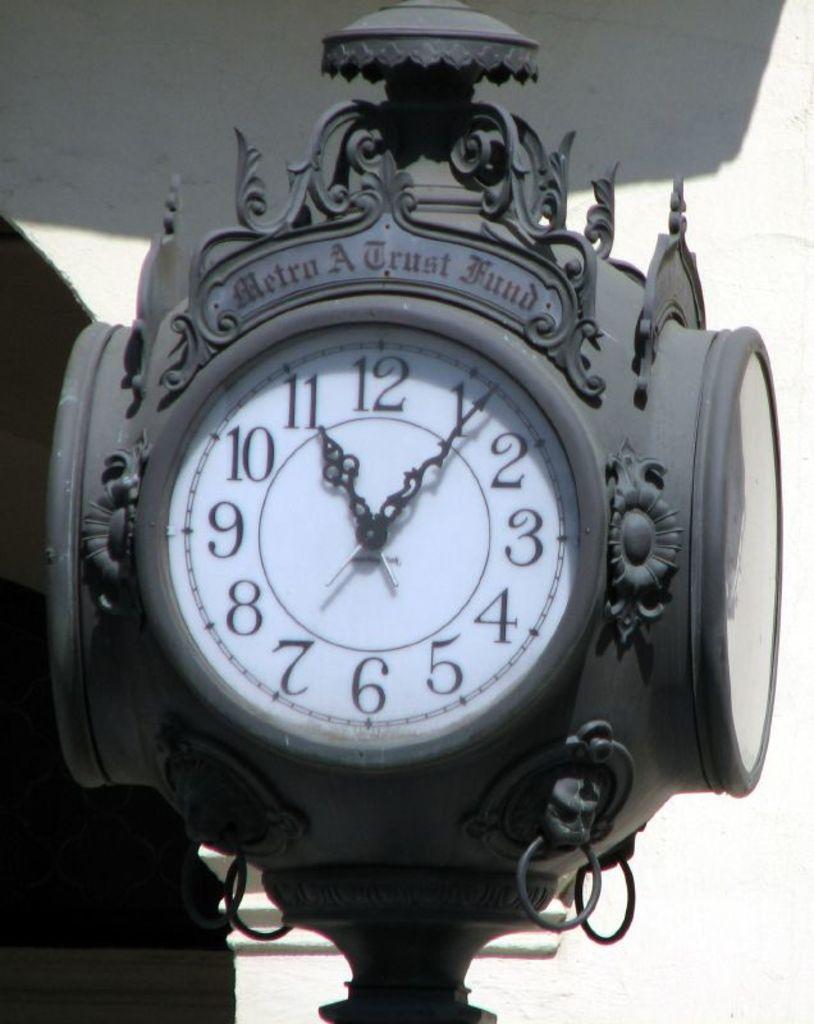What time is it?
Give a very brief answer. 11:06. How many hours till midnight?
Offer a terse response. 1. 